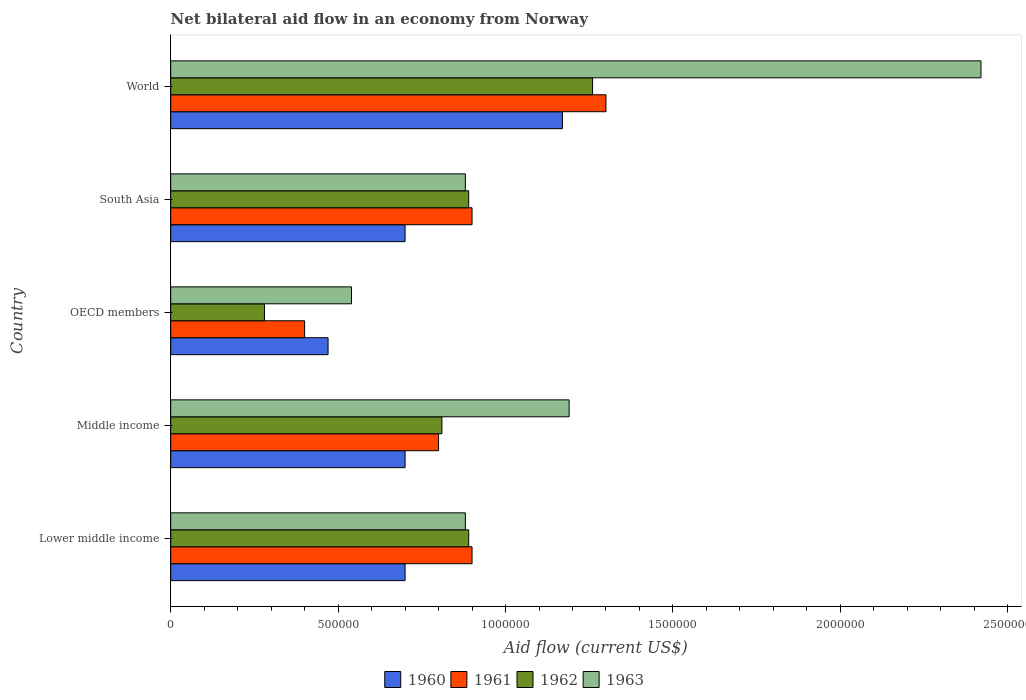How many bars are there on the 3rd tick from the top?
Your answer should be very brief. 4. In how many cases, is the number of bars for a given country not equal to the number of legend labels?
Your answer should be very brief. 0. What is the net bilateral aid flow in 1961 in World?
Ensure brevity in your answer.  1.30e+06. Across all countries, what is the maximum net bilateral aid flow in 1963?
Offer a very short reply. 2.42e+06. Across all countries, what is the minimum net bilateral aid flow in 1963?
Provide a succinct answer. 5.40e+05. In which country was the net bilateral aid flow in 1961 minimum?
Provide a succinct answer. OECD members. What is the total net bilateral aid flow in 1961 in the graph?
Your answer should be very brief. 4.30e+06. What is the difference between the net bilateral aid flow in 1963 in Middle income and that in OECD members?
Your response must be concise. 6.50e+05. What is the average net bilateral aid flow in 1961 per country?
Offer a very short reply. 8.60e+05. What is the difference between the net bilateral aid flow in 1960 and net bilateral aid flow in 1961 in World?
Make the answer very short. -1.30e+05. What is the ratio of the net bilateral aid flow in 1962 in Lower middle income to that in South Asia?
Give a very brief answer. 1. What is the difference between the highest and the second highest net bilateral aid flow in 1961?
Offer a very short reply. 4.00e+05. Are all the bars in the graph horizontal?
Your answer should be very brief. Yes. What is the difference between two consecutive major ticks on the X-axis?
Offer a very short reply. 5.00e+05. Are the values on the major ticks of X-axis written in scientific E-notation?
Your answer should be very brief. No. Does the graph contain grids?
Your answer should be compact. No. What is the title of the graph?
Your answer should be very brief. Net bilateral aid flow in an economy from Norway. What is the label or title of the X-axis?
Give a very brief answer. Aid flow (current US$). What is the label or title of the Y-axis?
Ensure brevity in your answer.  Country. What is the Aid flow (current US$) in 1960 in Lower middle income?
Make the answer very short. 7.00e+05. What is the Aid flow (current US$) of 1961 in Lower middle income?
Make the answer very short. 9.00e+05. What is the Aid flow (current US$) in 1962 in Lower middle income?
Ensure brevity in your answer.  8.90e+05. What is the Aid flow (current US$) of 1963 in Lower middle income?
Provide a succinct answer. 8.80e+05. What is the Aid flow (current US$) in 1960 in Middle income?
Your response must be concise. 7.00e+05. What is the Aid flow (current US$) of 1962 in Middle income?
Your answer should be compact. 8.10e+05. What is the Aid flow (current US$) in 1963 in Middle income?
Offer a very short reply. 1.19e+06. What is the Aid flow (current US$) in 1963 in OECD members?
Your answer should be compact. 5.40e+05. What is the Aid flow (current US$) in 1960 in South Asia?
Ensure brevity in your answer.  7.00e+05. What is the Aid flow (current US$) in 1962 in South Asia?
Provide a short and direct response. 8.90e+05. What is the Aid flow (current US$) of 1963 in South Asia?
Your answer should be compact. 8.80e+05. What is the Aid flow (current US$) of 1960 in World?
Make the answer very short. 1.17e+06. What is the Aid flow (current US$) in 1961 in World?
Your response must be concise. 1.30e+06. What is the Aid flow (current US$) in 1962 in World?
Make the answer very short. 1.26e+06. What is the Aid flow (current US$) in 1963 in World?
Your answer should be very brief. 2.42e+06. Across all countries, what is the maximum Aid flow (current US$) of 1960?
Provide a succinct answer. 1.17e+06. Across all countries, what is the maximum Aid flow (current US$) in 1961?
Offer a terse response. 1.30e+06. Across all countries, what is the maximum Aid flow (current US$) in 1962?
Keep it short and to the point. 1.26e+06. Across all countries, what is the maximum Aid flow (current US$) in 1963?
Keep it short and to the point. 2.42e+06. Across all countries, what is the minimum Aid flow (current US$) of 1962?
Provide a succinct answer. 2.80e+05. Across all countries, what is the minimum Aid flow (current US$) of 1963?
Provide a succinct answer. 5.40e+05. What is the total Aid flow (current US$) in 1960 in the graph?
Offer a very short reply. 3.74e+06. What is the total Aid flow (current US$) of 1961 in the graph?
Ensure brevity in your answer.  4.30e+06. What is the total Aid flow (current US$) of 1962 in the graph?
Offer a very short reply. 4.13e+06. What is the total Aid flow (current US$) in 1963 in the graph?
Provide a short and direct response. 5.91e+06. What is the difference between the Aid flow (current US$) of 1961 in Lower middle income and that in Middle income?
Your response must be concise. 1.00e+05. What is the difference between the Aid flow (current US$) in 1963 in Lower middle income and that in Middle income?
Keep it short and to the point. -3.10e+05. What is the difference between the Aid flow (current US$) of 1960 in Lower middle income and that in OECD members?
Ensure brevity in your answer.  2.30e+05. What is the difference between the Aid flow (current US$) in 1961 in Lower middle income and that in OECD members?
Your answer should be very brief. 5.00e+05. What is the difference between the Aid flow (current US$) in 1963 in Lower middle income and that in OECD members?
Your answer should be very brief. 3.40e+05. What is the difference between the Aid flow (current US$) of 1961 in Lower middle income and that in South Asia?
Your response must be concise. 0. What is the difference between the Aid flow (current US$) of 1962 in Lower middle income and that in South Asia?
Provide a succinct answer. 0. What is the difference between the Aid flow (current US$) of 1963 in Lower middle income and that in South Asia?
Give a very brief answer. 0. What is the difference between the Aid flow (current US$) in 1960 in Lower middle income and that in World?
Your response must be concise. -4.70e+05. What is the difference between the Aid flow (current US$) of 1961 in Lower middle income and that in World?
Offer a very short reply. -4.00e+05. What is the difference between the Aid flow (current US$) in 1962 in Lower middle income and that in World?
Give a very brief answer. -3.70e+05. What is the difference between the Aid flow (current US$) in 1963 in Lower middle income and that in World?
Your answer should be very brief. -1.54e+06. What is the difference between the Aid flow (current US$) of 1960 in Middle income and that in OECD members?
Your answer should be very brief. 2.30e+05. What is the difference between the Aid flow (current US$) in 1962 in Middle income and that in OECD members?
Give a very brief answer. 5.30e+05. What is the difference between the Aid flow (current US$) of 1963 in Middle income and that in OECD members?
Offer a very short reply. 6.50e+05. What is the difference between the Aid flow (current US$) of 1963 in Middle income and that in South Asia?
Your answer should be very brief. 3.10e+05. What is the difference between the Aid flow (current US$) of 1960 in Middle income and that in World?
Your answer should be very brief. -4.70e+05. What is the difference between the Aid flow (current US$) in 1961 in Middle income and that in World?
Offer a terse response. -5.00e+05. What is the difference between the Aid flow (current US$) of 1962 in Middle income and that in World?
Offer a terse response. -4.50e+05. What is the difference between the Aid flow (current US$) in 1963 in Middle income and that in World?
Provide a short and direct response. -1.23e+06. What is the difference between the Aid flow (current US$) in 1961 in OECD members and that in South Asia?
Your answer should be very brief. -5.00e+05. What is the difference between the Aid flow (current US$) of 1962 in OECD members and that in South Asia?
Give a very brief answer. -6.10e+05. What is the difference between the Aid flow (current US$) of 1963 in OECD members and that in South Asia?
Keep it short and to the point. -3.40e+05. What is the difference between the Aid flow (current US$) in 1960 in OECD members and that in World?
Provide a succinct answer. -7.00e+05. What is the difference between the Aid flow (current US$) of 1961 in OECD members and that in World?
Offer a terse response. -9.00e+05. What is the difference between the Aid flow (current US$) of 1962 in OECD members and that in World?
Provide a succinct answer. -9.80e+05. What is the difference between the Aid flow (current US$) in 1963 in OECD members and that in World?
Offer a terse response. -1.88e+06. What is the difference between the Aid flow (current US$) of 1960 in South Asia and that in World?
Offer a terse response. -4.70e+05. What is the difference between the Aid flow (current US$) of 1961 in South Asia and that in World?
Provide a short and direct response. -4.00e+05. What is the difference between the Aid flow (current US$) of 1962 in South Asia and that in World?
Provide a short and direct response. -3.70e+05. What is the difference between the Aid flow (current US$) of 1963 in South Asia and that in World?
Ensure brevity in your answer.  -1.54e+06. What is the difference between the Aid flow (current US$) of 1960 in Lower middle income and the Aid flow (current US$) of 1961 in Middle income?
Offer a very short reply. -1.00e+05. What is the difference between the Aid flow (current US$) of 1960 in Lower middle income and the Aid flow (current US$) of 1963 in Middle income?
Offer a very short reply. -4.90e+05. What is the difference between the Aid flow (current US$) of 1961 in Lower middle income and the Aid flow (current US$) of 1963 in Middle income?
Provide a succinct answer. -2.90e+05. What is the difference between the Aid flow (current US$) of 1962 in Lower middle income and the Aid flow (current US$) of 1963 in Middle income?
Your response must be concise. -3.00e+05. What is the difference between the Aid flow (current US$) in 1960 in Lower middle income and the Aid flow (current US$) in 1961 in OECD members?
Your answer should be very brief. 3.00e+05. What is the difference between the Aid flow (current US$) in 1960 in Lower middle income and the Aid flow (current US$) in 1963 in OECD members?
Provide a succinct answer. 1.60e+05. What is the difference between the Aid flow (current US$) of 1961 in Lower middle income and the Aid flow (current US$) of 1962 in OECD members?
Make the answer very short. 6.20e+05. What is the difference between the Aid flow (current US$) in 1960 in Lower middle income and the Aid flow (current US$) in 1962 in South Asia?
Your answer should be very brief. -1.90e+05. What is the difference between the Aid flow (current US$) in 1961 in Lower middle income and the Aid flow (current US$) in 1962 in South Asia?
Make the answer very short. 10000. What is the difference between the Aid flow (current US$) of 1962 in Lower middle income and the Aid flow (current US$) of 1963 in South Asia?
Make the answer very short. 10000. What is the difference between the Aid flow (current US$) of 1960 in Lower middle income and the Aid flow (current US$) of 1961 in World?
Offer a terse response. -6.00e+05. What is the difference between the Aid flow (current US$) in 1960 in Lower middle income and the Aid flow (current US$) in 1962 in World?
Your answer should be very brief. -5.60e+05. What is the difference between the Aid flow (current US$) in 1960 in Lower middle income and the Aid flow (current US$) in 1963 in World?
Your answer should be compact. -1.72e+06. What is the difference between the Aid flow (current US$) of 1961 in Lower middle income and the Aid flow (current US$) of 1962 in World?
Offer a very short reply. -3.60e+05. What is the difference between the Aid flow (current US$) in 1961 in Lower middle income and the Aid flow (current US$) in 1963 in World?
Your response must be concise. -1.52e+06. What is the difference between the Aid flow (current US$) of 1962 in Lower middle income and the Aid flow (current US$) of 1963 in World?
Offer a terse response. -1.53e+06. What is the difference between the Aid flow (current US$) of 1960 in Middle income and the Aid flow (current US$) of 1961 in OECD members?
Your answer should be very brief. 3.00e+05. What is the difference between the Aid flow (current US$) of 1960 in Middle income and the Aid flow (current US$) of 1962 in OECD members?
Keep it short and to the point. 4.20e+05. What is the difference between the Aid flow (current US$) in 1961 in Middle income and the Aid flow (current US$) in 1962 in OECD members?
Keep it short and to the point. 5.20e+05. What is the difference between the Aid flow (current US$) of 1961 in Middle income and the Aid flow (current US$) of 1963 in OECD members?
Your answer should be very brief. 2.60e+05. What is the difference between the Aid flow (current US$) in 1962 in Middle income and the Aid flow (current US$) in 1963 in OECD members?
Offer a terse response. 2.70e+05. What is the difference between the Aid flow (current US$) of 1962 in Middle income and the Aid flow (current US$) of 1963 in South Asia?
Offer a very short reply. -7.00e+04. What is the difference between the Aid flow (current US$) of 1960 in Middle income and the Aid flow (current US$) of 1961 in World?
Your response must be concise. -6.00e+05. What is the difference between the Aid flow (current US$) of 1960 in Middle income and the Aid flow (current US$) of 1962 in World?
Provide a short and direct response. -5.60e+05. What is the difference between the Aid flow (current US$) of 1960 in Middle income and the Aid flow (current US$) of 1963 in World?
Your answer should be very brief. -1.72e+06. What is the difference between the Aid flow (current US$) of 1961 in Middle income and the Aid flow (current US$) of 1962 in World?
Keep it short and to the point. -4.60e+05. What is the difference between the Aid flow (current US$) of 1961 in Middle income and the Aid flow (current US$) of 1963 in World?
Provide a short and direct response. -1.62e+06. What is the difference between the Aid flow (current US$) of 1962 in Middle income and the Aid flow (current US$) of 1963 in World?
Keep it short and to the point. -1.61e+06. What is the difference between the Aid flow (current US$) of 1960 in OECD members and the Aid flow (current US$) of 1961 in South Asia?
Keep it short and to the point. -4.30e+05. What is the difference between the Aid flow (current US$) in 1960 in OECD members and the Aid flow (current US$) in 1962 in South Asia?
Ensure brevity in your answer.  -4.20e+05. What is the difference between the Aid flow (current US$) in 1960 in OECD members and the Aid flow (current US$) in 1963 in South Asia?
Provide a succinct answer. -4.10e+05. What is the difference between the Aid flow (current US$) of 1961 in OECD members and the Aid flow (current US$) of 1962 in South Asia?
Offer a terse response. -4.90e+05. What is the difference between the Aid flow (current US$) in 1961 in OECD members and the Aid flow (current US$) in 1963 in South Asia?
Your answer should be compact. -4.80e+05. What is the difference between the Aid flow (current US$) of 1962 in OECD members and the Aid flow (current US$) of 1963 in South Asia?
Offer a very short reply. -6.00e+05. What is the difference between the Aid flow (current US$) of 1960 in OECD members and the Aid flow (current US$) of 1961 in World?
Provide a succinct answer. -8.30e+05. What is the difference between the Aid flow (current US$) in 1960 in OECD members and the Aid flow (current US$) in 1962 in World?
Make the answer very short. -7.90e+05. What is the difference between the Aid flow (current US$) in 1960 in OECD members and the Aid flow (current US$) in 1963 in World?
Your answer should be compact. -1.95e+06. What is the difference between the Aid flow (current US$) of 1961 in OECD members and the Aid flow (current US$) of 1962 in World?
Provide a succinct answer. -8.60e+05. What is the difference between the Aid flow (current US$) of 1961 in OECD members and the Aid flow (current US$) of 1963 in World?
Your answer should be compact. -2.02e+06. What is the difference between the Aid flow (current US$) of 1962 in OECD members and the Aid flow (current US$) of 1963 in World?
Your response must be concise. -2.14e+06. What is the difference between the Aid flow (current US$) in 1960 in South Asia and the Aid flow (current US$) in 1961 in World?
Make the answer very short. -6.00e+05. What is the difference between the Aid flow (current US$) in 1960 in South Asia and the Aid flow (current US$) in 1962 in World?
Make the answer very short. -5.60e+05. What is the difference between the Aid flow (current US$) of 1960 in South Asia and the Aid flow (current US$) of 1963 in World?
Your response must be concise. -1.72e+06. What is the difference between the Aid flow (current US$) of 1961 in South Asia and the Aid flow (current US$) of 1962 in World?
Make the answer very short. -3.60e+05. What is the difference between the Aid flow (current US$) of 1961 in South Asia and the Aid flow (current US$) of 1963 in World?
Give a very brief answer. -1.52e+06. What is the difference between the Aid flow (current US$) in 1962 in South Asia and the Aid flow (current US$) in 1963 in World?
Give a very brief answer. -1.53e+06. What is the average Aid flow (current US$) in 1960 per country?
Your response must be concise. 7.48e+05. What is the average Aid flow (current US$) in 1961 per country?
Your answer should be very brief. 8.60e+05. What is the average Aid flow (current US$) in 1962 per country?
Your answer should be compact. 8.26e+05. What is the average Aid flow (current US$) in 1963 per country?
Your answer should be compact. 1.18e+06. What is the difference between the Aid flow (current US$) of 1960 and Aid flow (current US$) of 1963 in Lower middle income?
Provide a succinct answer. -1.80e+05. What is the difference between the Aid flow (current US$) of 1961 and Aid flow (current US$) of 1963 in Lower middle income?
Your answer should be very brief. 2.00e+04. What is the difference between the Aid flow (current US$) of 1962 and Aid flow (current US$) of 1963 in Lower middle income?
Make the answer very short. 10000. What is the difference between the Aid flow (current US$) in 1960 and Aid flow (current US$) in 1961 in Middle income?
Provide a short and direct response. -1.00e+05. What is the difference between the Aid flow (current US$) in 1960 and Aid flow (current US$) in 1962 in Middle income?
Give a very brief answer. -1.10e+05. What is the difference between the Aid flow (current US$) in 1960 and Aid flow (current US$) in 1963 in Middle income?
Provide a short and direct response. -4.90e+05. What is the difference between the Aid flow (current US$) in 1961 and Aid flow (current US$) in 1962 in Middle income?
Your answer should be compact. -10000. What is the difference between the Aid flow (current US$) of 1961 and Aid flow (current US$) of 1963 in Middle income?
Your answer should be very brief. -3.90e+05. What is the difference between the Aid flow (current US$) in 1962 and Aid flow (current US$) in 1963 in Middle income?
Provide a succinct answer. -3.80e+05. What is the difference between the Aid flow (current US$) in 1960 and Aid flow (current US$) in 1961 in OECD members?
Provide a short and direct response. 7.00e+04. What is the difference between the Aid flow (current US$) in 1960 and Aid flow (current US$) in 1962 in OECD members?
Make the answer very short. 1.90e+05. What is the difference between the Aid flow (current US$) in 1960 and Aid flow (current US$) in 1963 in OECD members?
Ensure brevity in your answer.  -7.00e+04. What is the difference between the Aid flow (current US$) in 1961 and Aid flow (current US$) in 1962 in OECD members?
Your response must be concise. 1.20e+05. What is the difference between the Aid flow (current US$) of 1961 and Aid flow (current US$) of 1962 in South Asia?
Keep it short and to the point. 10000. What is the difference between the Aid flow (current US$) in 1960 and Aid flow (current US$) in 1961 in World?
Offer a very short reply. -1.30e+05. What is the difference between the Aid flow (current US$) of 1960 and Aid flow (current US$) of 1962 in World?
Give a very brief answer. -9.00e+04. What is the difference between the Aid flow (current US$) of 1960 and Aid flow (current US$) of 1963 in World?
Your answer should be very brief. -1.25e+06. What is the difference between the Aid flow (current US$) in 1961 and Aid flow (current US$) in 1963 in World?
Your answer should be very brief. -1.12e+06. What is the difference between the Aid flow (current US$) of 1962 and Aid flow (current US$) of 1963 in World?
Your response must be concise. -1.16e+06. What is the ratio of the Aid flow (current US$) of 1962 in Lower middle income to that in Middle income?
Make the answer very short. 1.1. What is the ratio of the Aid flow (current US$) of 1963 in Lower middle income to that in Middle income?
Your answer should be compact. 0.74. What is the ratio of the Aid flow (current US$) of 1960 in Lower middle income to that in OECD members?
Your response must be concise. 1.49. What is the ratio of the Aid flow (current US$) of 1961 in Lower middle income to that in OECD members?
Give a very brief answer. 2.25. What is the ratio of the Aid flow (current US$) in 1962 in Lower middle income to that in OECD members?
Provide a short and direct response. 3.18. What is the ratio of the Aid flow (current US$) in 1963 in Lower middle income to that in OECD members?
Offer a very short reply. 1.63. What is the ratio of the Aid flow (current US$) in 1961 in Lower middle income to that in South Asia?
Your answer should be compact. 1. What is the ratio of the Aid flow (current US$) in 1963 in Lower middle income to that in South Asia?
Provide a short and direct response. 1. What is the ratio of the Aid flow (current US$) in 1960 in Lower middle income to that in World?
Make the answer very short. 0.6. What is the ratio of the Aid flow (current US$) of 1961 in Lower middle income to that in World?
Provide a short and direct response. 0.69. What is the ratio of the Aid flow (current US$) of 1962 in Lower middle income to that in World?
Your answer should be very brief. 0.71. What is the ratio of the Aid flow (current US$) in 1963 in Lower middle income to that in World?
Ensure brevity in your answer.  0.36. What is the ratio of the Aid flow (current US$) in 1960 in Middle income to that in OECD members?
Offer a terse response. 1.49. What is the ratio of the Aid flow (current US$) of 1962 in Middle income to that in OECD members?
Keep it short and to the point. 2.89. What is the ratio of the Aid flow (current US$) in 1963 in Middle income to that in OECD members?
Provide a short and direct response. 2.2. What is the ratio of the Aid flow (current US$) in 1960 in Middle income to that in South Asia?
Offer a terse response. 1. What is the ratio of the Aid flow (current US$) in 1962 in Middle income to that in South Asia?
Keep it short and to the point. 0.91. What is the ratio of the Aid flow (current US$) in 1963 in Middle income to that in South Asia?
Provide a succinct answer. 1.35. What is the ratio of the Aid flow (current US$) in 1960 in Middle income to that in World?
Offer a very short reply. 0.6. What is the ratio of the Aid flow (current US$) of 1961 in Middle income to that in World?
Ensure brevity in your answer.  0.62. What is the ratio of the Aid flow (current US$) of 1962 in Middle income to that in World?
Ensure brevity in your answer.  0.64. What is the ratio of the Aid flow (current US$) of 1963 in Middle income to that in World?
Your answer should be very brief. 0.49. What is the ratio of the Aid flow (current US$) in 1960 in OECD members to that in South Asia?
Give a very brief answer. 0.67. What is the ratio of the Aid flow (current US$) of 1961 in OECD members to that in South Asia?
Your answer should be compact. 0.44. What is the ratio of the Aid flow (current US$) in 1962 in OECD members to that in South Asia?
Keep it short and to the point. 0.31. What is the ratio of the Aid flow (current US$) in 1963 in OECD members to that in South Asia?
Offer a terse response. 0.61. What is the ratio of the Aid flow (current US$) of 1960 in OECD members to that in World?
Offer a very short reply. 0.4. What is the ratio of the Aid flow (current US$) of 1961 in OECD members to that in World?
Offer a terse response. 0.31. What is the ratio of the Aid flow (current US$) in 1962 in OECD members to that in World?
Provide a short and direct response. 0.22. What is the ratio of the Aid flow (current US$) in 1963 in OECD members to that in World?
Offer a terse response. 0.22. What is the ratio of the Aid flow (current US$) in 1960 in South Asia to that in World?
Your response must be concise. 0.6. What is the ratio of the Aid flow (current US$) of 1961 in South Asia to that in World?
Provide a short and direct response. 0.69. What is the ratio of the Aid flow (current US$) in 1962 in South Asia to that in World?
Your answer should be compact. 0.71. What is the ratio of the Aid flow (current US$) in 1963 in South Asia to that in World?
Your answer should be very brief. 0.36. What is the difference between the highest and the second highest Aid flow (current US$) in 1961?
Provide a short and direct response. 4.00e+05. What is the difference between the highest and the second highest Aid flow (current US$) in 1962?
Your response must be concise. 3.70e+05. What is the difference between the highest and the second highest Aid flow (current US$) in 1963?
Provide a succinct answer. 1.23e+06. What is the difference between the highest and the lowest Aid flow (current US$) of 1962?
Make the answer very short. 9.80e+05. What is the difference between the highest and the lowest Aid flow (current US$) in 1963?
Offer a terse response. 1.88e+06. 